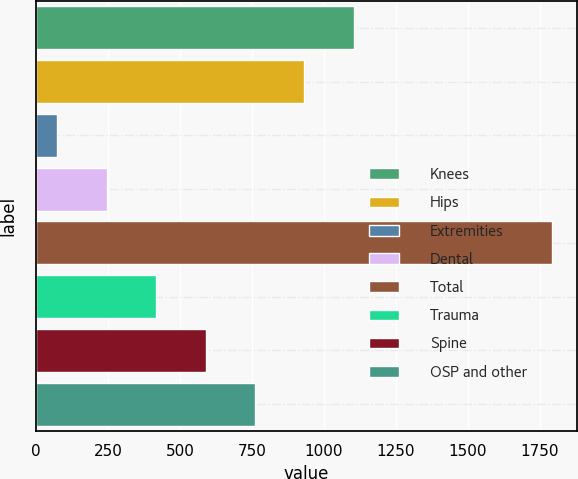<chart> <loc_0><loc_0><loc_500><loc_500><bar_chart><fcel>Knees<fcel>Hips<fcel>Extremities<fcel>Dental<fcel>Total<fcel>Trauma<fcel>Spine<fcel>OSP and other<nl><fcel>1104.1<fcel>932.4<fcel>73.9<fcel>245.6<fcel>1790.9<fcel>417.3<fcel>589<fcel>760.7<nl></chart> 